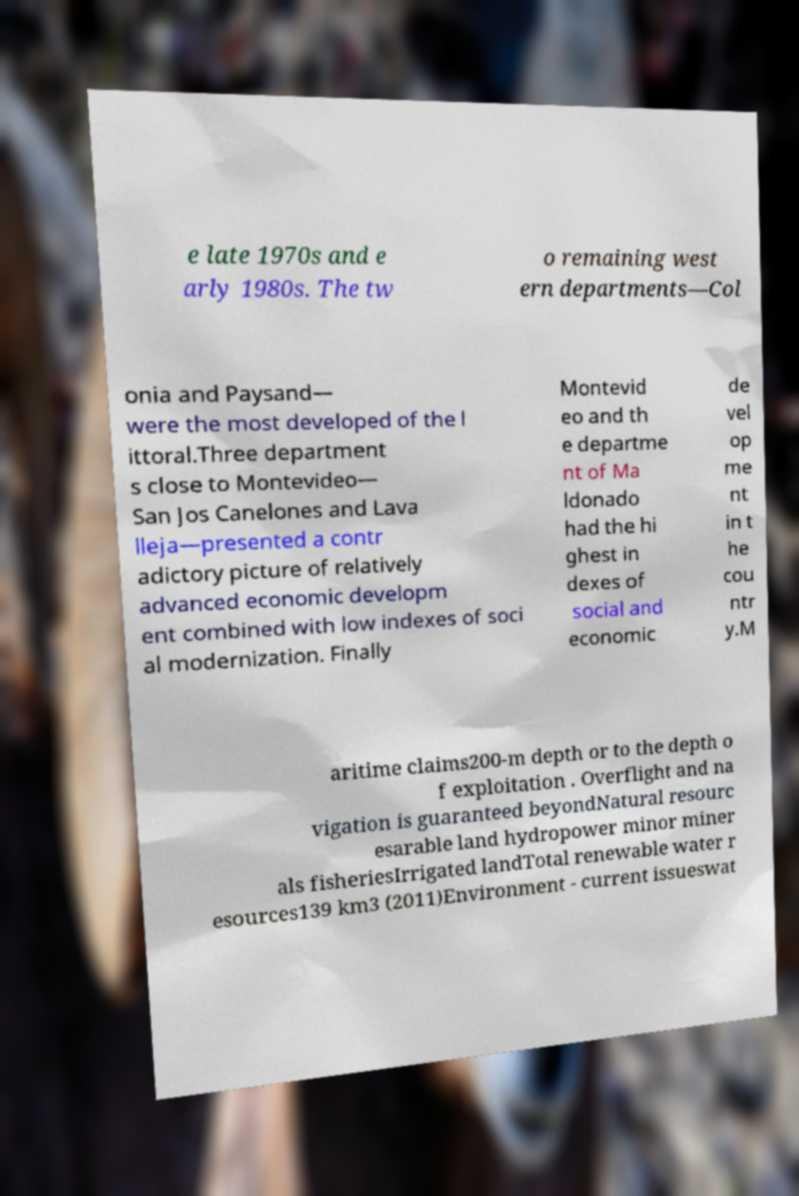There's text embedded in this image that I need extracted. Can you transcribe it verbatim? e late 1970s and e arly 1980s. The tw o remaining west ern departments—Col onia and Paysand— were the most developed of the l ittoral.Three department s close to Montevideo— San Jos Canelones and Lava lleja—presented a contr adictory picture of relatively advanced economic developm ent combined with low indexes of soci al modernization. Finally Montevid eo and th e departme nt of Ma ldonado had the hi ghest in dexes of social and economic de vel op me nt in t he cou ntr y.M aritime claims200-m depth or to the depth o f exploitation . Overflight and na vigation is guaranteed beyondNatural resourc esarable land hydropower minor miner als fisheriesIrrigated landTotal renewable water r esources139 km3 (2011)Environment - current issueswat 